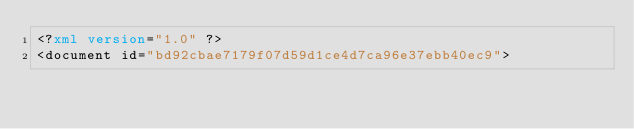Convert code to text. <code><loc_0><loc_0><loc_500><loc_500><_XML_><?xml version="1.0" ?>
<document id="bd92cbae7179f07d59d1ce4d7ca96e37ebb40ec9"></code> 